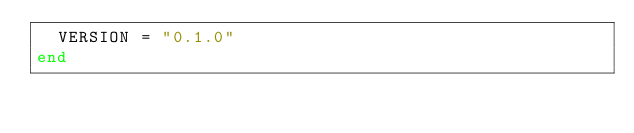<code> <loc_0><loc_0><loc_500><loc_500><_Crystal_>  VERSION = "0.1.0"
end
</code> 